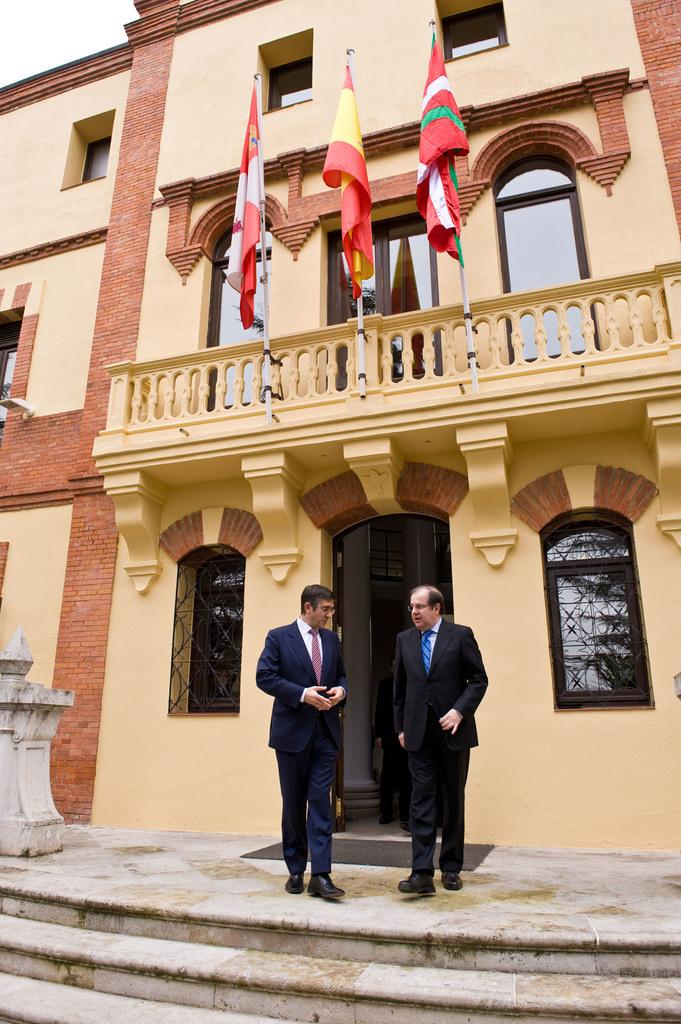What type of structure is present in the image? There is a building in the image. What can be seen flying in the image? There are flags in the image. What architectural feature is visible in the image? There are stairs in the image. What are the two people wearing in the image? The two people are wearing black color jackets. What is visible at the top of the image? The sky is visible at the top of the image. How does the ice cream move around in the image? The ice cream does not move around in the image; it is stationary in the bowl. 